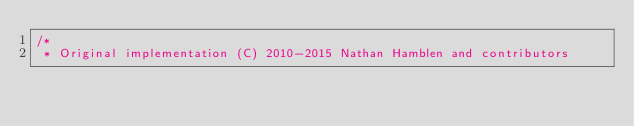Convert code to text. <code><loc_0><loc_0><loc_500><loc_500><_Scala_>/*
 * Original implementation (C) 2010-2015 Nathan Hamblen and contributors</code> 